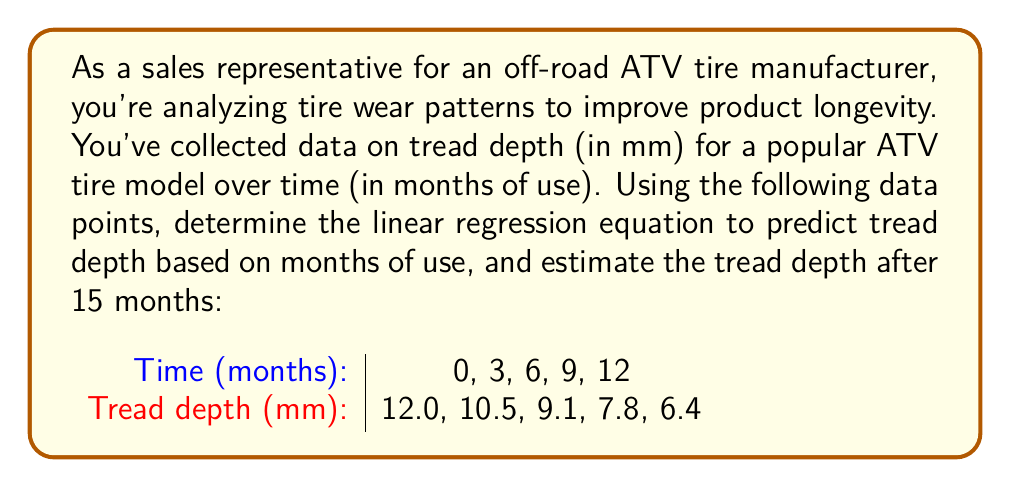Teach me how to tackle this problem. To solve this problem, we'll use linear regression to find the line of best fit for the given data points. Then we'll use the resulting equation to predict the tread depth after 15 months.

Step 1: Calculate the means of x (time) and y (tread depth)
$\bar{x} = \frac{0 + 3 + 6 + 9 + 12}{5} = 6$
$\bar{y} = \frac{12.0 + 10.5 + 9.1 + 7.8 + 6.4}{5} = 9.16$

Step 2: Calculate the slope (m) using the formula:
$m = \frac{\sum(x_i - \bar{x})(y_i - \bar{y})}{\sum(x_i - \bar{x})^2}$

$\sum(x_i - \bar{x})(y_i - \bar{y}) = (-6)(2.84) + (-3)(1.34) + (0)(-0.06) + (3)(-1.36) + (6)(-2.76) = -34.02$
$\sum(x_i - \bar{x})^2 = (-6)^2 + (-3)^2 + (0)^2 + (3)^2 + (6)^2 = 90$

$m = \frac{-34.02}{90} = -0.378$

Step 3: Calculate the y-intercept (b) using the formula:
$b = \bar{y} - m\bar{x}$
$b = 9.16 - (-0.378)(6) = 11.428$

Step 4: Write the linear regression equation:
$y = mx + b$
$y = -0.378x + 11.428$

Step 5: Use the equation to predict tread depth at 15 months:
$y = -0.378(15) + 11.428 = 5.758$
Answer: The linear regression equation is $y = -0.378x + 11.428$, where $y$ is the tread depth in mm and $x$ is the time in months. The estimated tread depth after 15 months of use is 5.758 mm. 